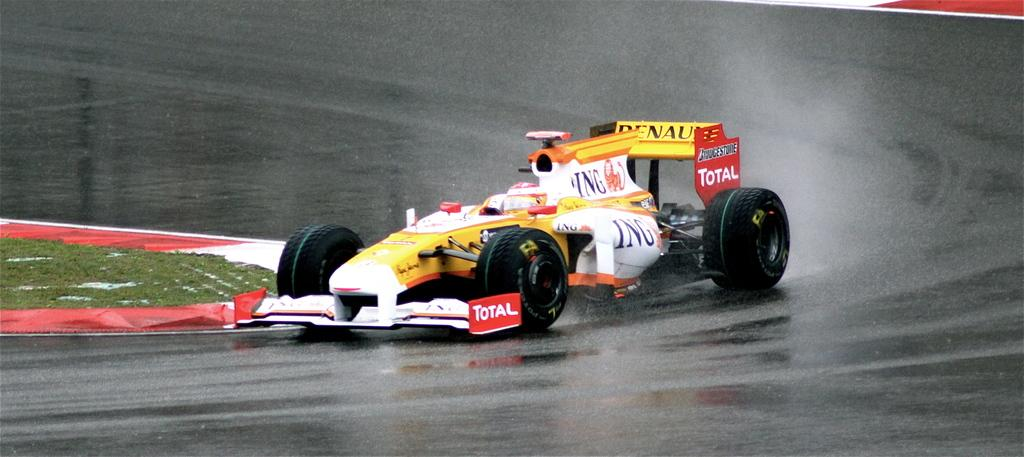What color is the vehicle in the image? The vehicle in the image is yellow. What is the condition of the road in the image? The road in the image appears to be wet. What type of vegetation can be seen on the left side of the image? There is grass visible on the left side of the image. What type of card is being used to play a game in the image? There is no card or game present in the image; it features a yellow vehicle and a wet road. What type of drink is being consumed by the person in the image? There is no person or drink present in the image. 